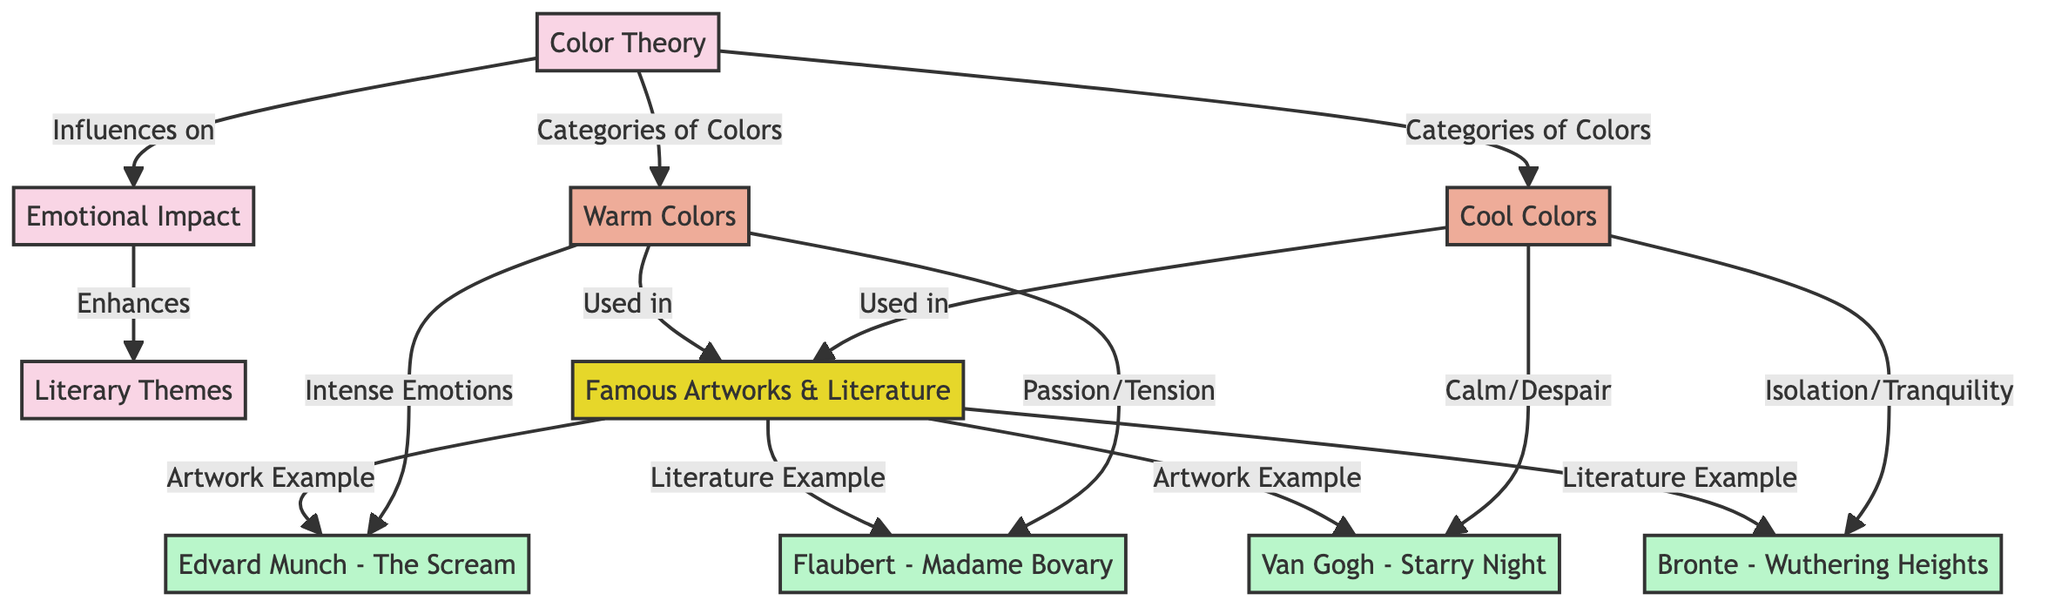What are the two categories of colors mentioned in the diagram? The diagram explicitly states "Warm Colors" and "Cool Colors" as the categories derived from "Color Theory."
Answer: Warm Colors, Cool Colors Which famous artwork is linked to intense emotions? Following the flow from "Warm Colors" to "Emotive Examples," it shows that "The Scream" by Edvard Munch is specifically associated with intense emotions.
Answer: The Scream How many literary examples are provided in the diagram? Upon examining "Emotive Examples," we can see that there are two literary examples listed: "Madame Bovary" and "Wuthering Heights."
Answer: 2 What emotional effect do cool colors have according to the diagram? The flow indicates that cool colors are associated with feelings of "Calm" and "Despair," as shown under the connections to the examples provided.
Answer: Calm/Despair Which connection comes before "Literary Themes" in the diagram? The diagram shows that "Emotional Impact" has a direct influence on "Literary Themes," so this connection clearly precedes it.
Answer: Emotional Impact What theme is associated with warm colors in Flaubert's "Madame Bovary"? According to the diagram, "Madame Bovary" is linked to "Passion/Tension," which are emotions typically associated with warm colors.
Answer: Passion/Tension What do "Color Theory" and "Emotional Impact" have in common in their relationship? Both "Color Theory" and "Emotional Impact" are connected in that Color Theory influences Emotional Impact, indicating a cause-effect relationship.
Answer: Influence Which artwork is linked with "Isolation" and "Tranquility"? The diagram establishes that the "Wuthering Heights" connection to cool colors reflects feelings of "Isolation/Tranquility."
Answer: Wuthering Heights 